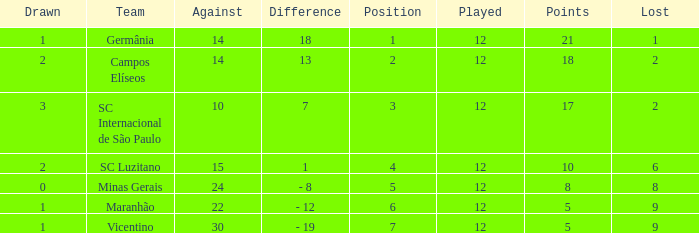What is the sum of drawn that has a played more than 12? 0.0. 